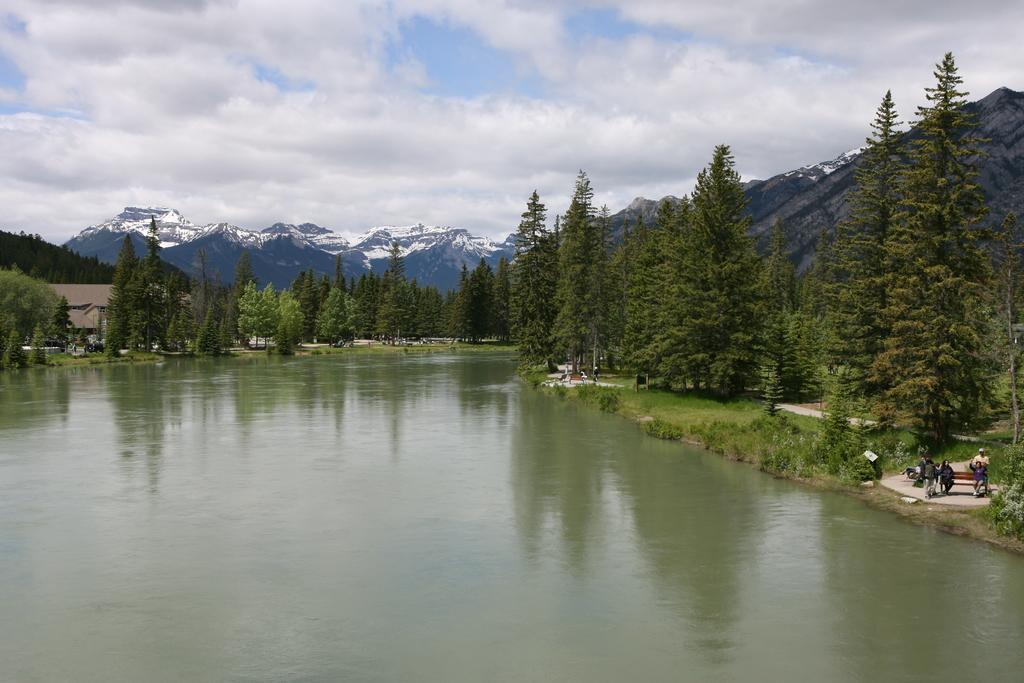Could you give a brief overview of what you see in this image? At the bottom of the image there is water and few people are standing. In the middle of the image there are some trees and hills and buildings. 